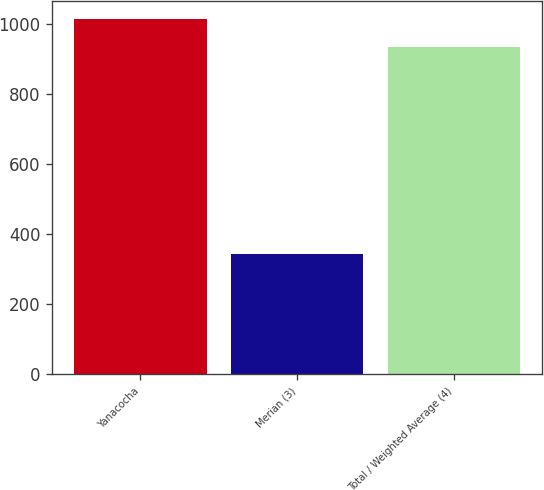Convert chart to OTSL. <chart><loc_0><loc_0><loc_500><loc_500><bar_chart><fcel>Yanacocha<fcel>Merian (3)<fcel>Total / Weighted Average (4)<nl><fcel>1014<fcel>344<fcel>932<nl></chart> 